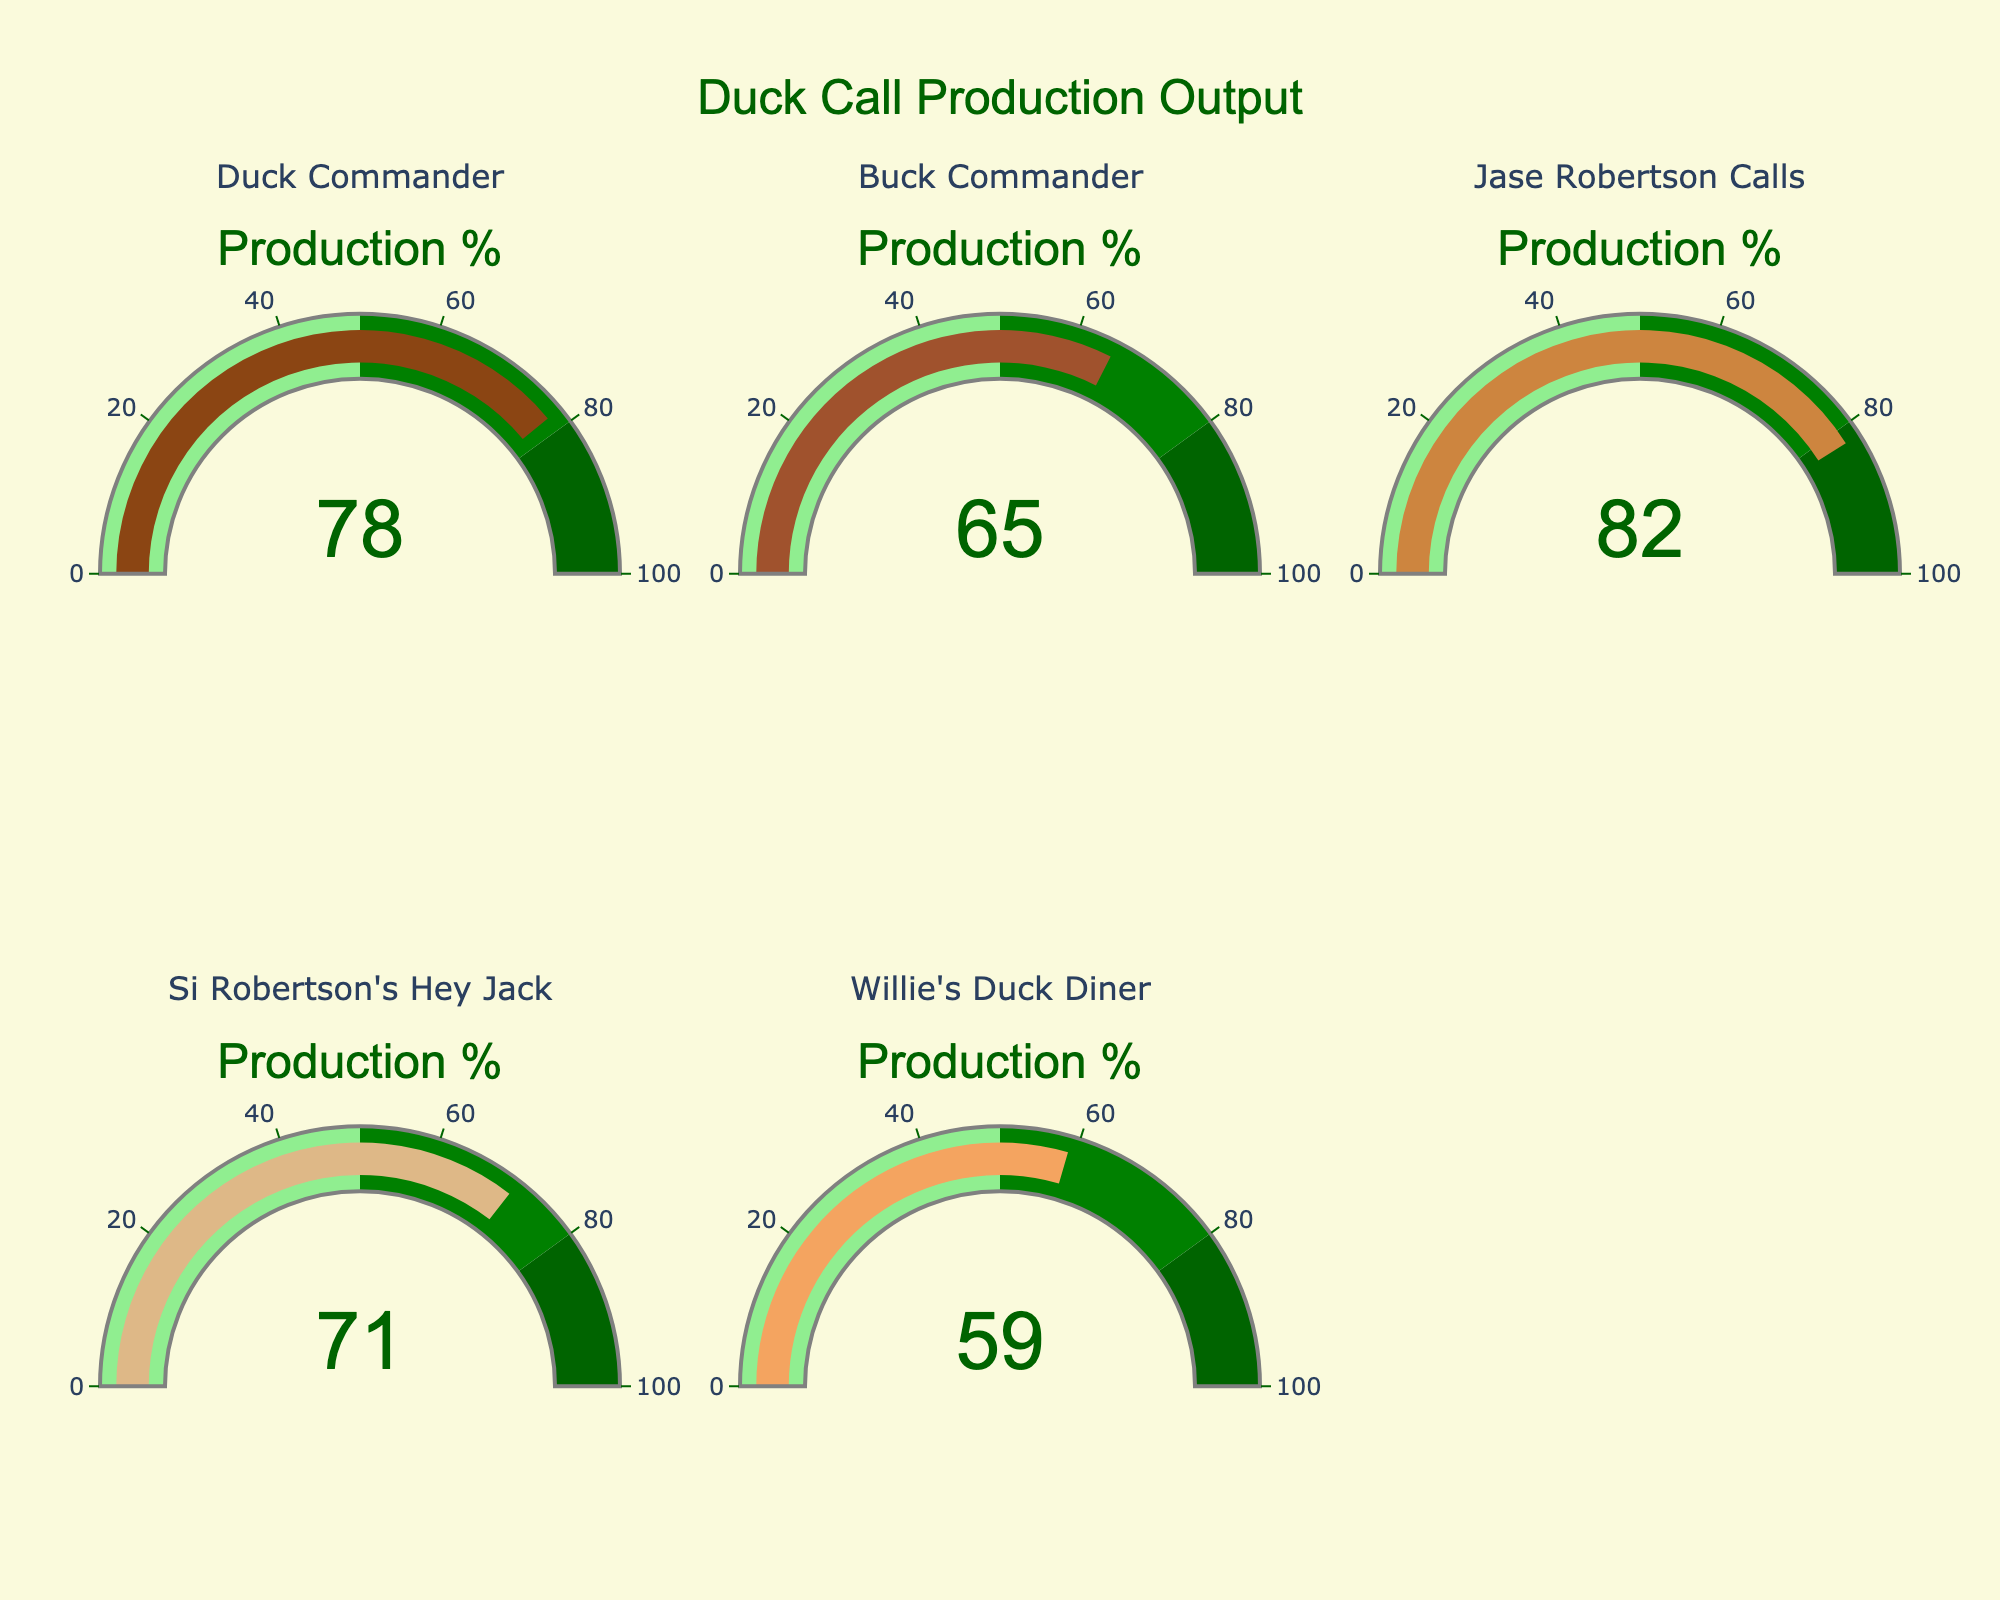Which company has the highest production percentage? To find the highest production percentage, look at the gauge for each company and see which one shows the highest number. Jase Robertson Calls shows 82%, which is the highest.
Answer: Jase Robertson Calls Which company has the lowest production percentage? To find the lowest production percentage, look at the gauges for each company and see which one shows the lowest number. Willie's Duck Diner shows 59%, which is the lowest.
Answer: Willie's Duck Diner What is the production percentage of Duck Commander? Look at the gauge labeled Duck Commander and read the number displayed in the center of the gauge. It shows 78%.
Answer: 78% What is the average production percentage of all the companies? Add all the production percentages together and then divide by the number of companies: (78 + 65 + 82 + 71 + 59) / 5 = 355 / 5 = 71
Answer: 71 How much greater is Jase Robertson Calls' production percentage compared to Buck Commander's? Subtract Buck Commander's percentage from Jase Robertson Calls’ percentage: 82 - 65 = 17
Answer: 17 Which companies have a production percentage above 70%? Look at the gauges and identify which ones have a production percentage above 70%. Duck Commander (78%), Jase Robertson Calls (82%), and Si Robertson's Hey Jack (71%).
Answer: Duck Commander, Jase Robertson Calls, Si Robertson's Hey Jack What's the total production percentage for Buck Commander and Willie's Duck Diner combined? Add the production percentages of Buck Commander and Willie's Duck Diner: 65 + 59 = 124
Answer: 124 Which company has a production percentage closest to the average production percentage of all companies? First, calculate the average (found to be 71), then find the company whose production percentage is closest to 71. Si Robertson's Hey Jack has a production percentage of 71, which is exactly the same as the average.
Answer: Si Robertson's Hey Jack Which companies have production percentages within the green range of the gauge (50-80%)? Look at the gauges and identify which ones have a production percentage within the 50-80% range. Duck Commander (78%), Buck Commander (65%), Si Robertson's Hey Jack (71%).
Answer: Duck Commander, Buck Commander, Si Robertson's Hey Jack 